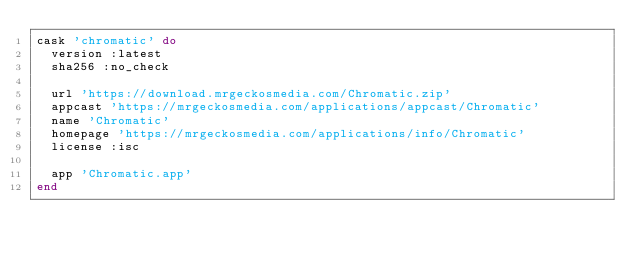Convert code to text. <code><loc_0><loc_0><loc_500><loc_500><_Ruby_>cask 'chromatic' do
  version :latest
  sha256 :no_check

  url 'https://download.mrgeckosmedia.com/Chromatic.zip'
  appcast 'https://mrgeckosmedia.com/applications/appcast/Chromatic'
  name 'Chromatic'
  homepage 'https://mrgeckosmedia.com/applications/info/Chromatic'
  license :isc

  app 'Chromatic.app'
end
</code> 